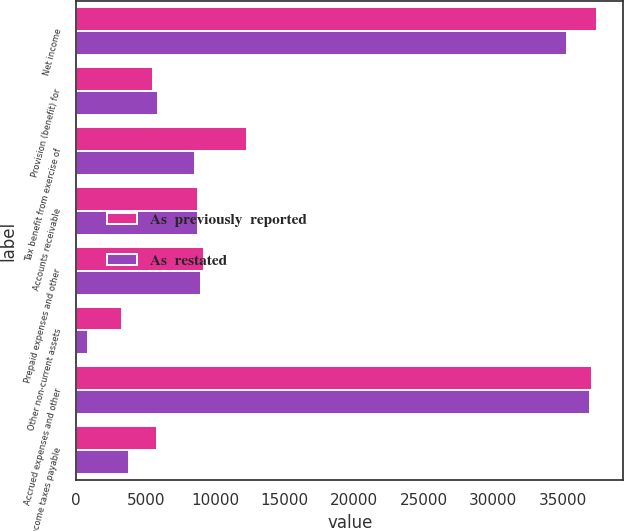<chart> <loc_0><loc_0><loc_500><loc_500><stacked_bar_chart><ecel><fcel>Net income<fcel>Provision (benefit) for<fcel>Tax benefit from exercise of<fcel>Accounts receivable<fcel>Prepaid expenses and other<fcel>Other non-current assets<fcel>Accrued expenses and other<fcel>Income taxes payable<nl><fcel>As  previously  reported<fcel>37475<fcel>5531<fcel>12286<fcel>8736.5<fcel>9174<fcel>3306<fcel>37099<fcel>5797<nl><fcel>As  restated<fcel>35314<fcel>5910<fcel>8534<fcel>8736.5<fcel>8939<fcel>830<fcel>36991<fcel>3812<nl></chart> 